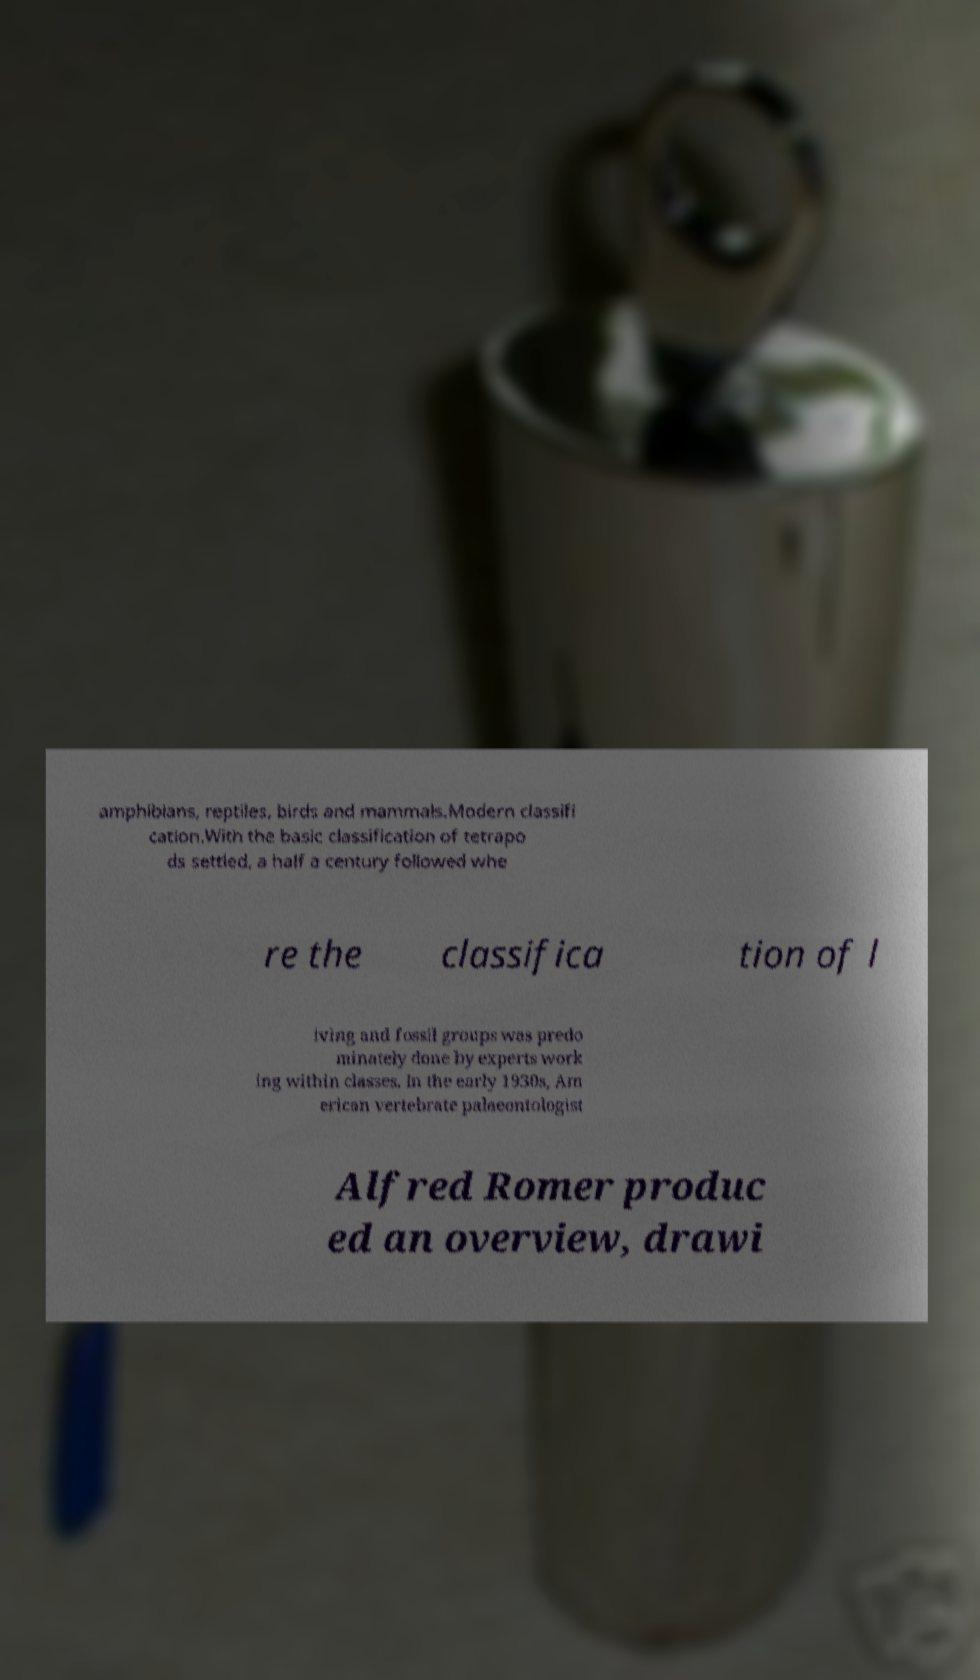Could you extract and type out the text from this image? amphibians, reptiles, birds and mammals.Modern classifi cation.With the basic classification of tetrapo ds settled, a half a century followed whe re the classifica tion of l iving and fossil groups was predo minately done by experts work ing within classes. In the early 1930s, Am erican vertebrate palaeontologist Alfred Romer produc ed an overview, drawi 